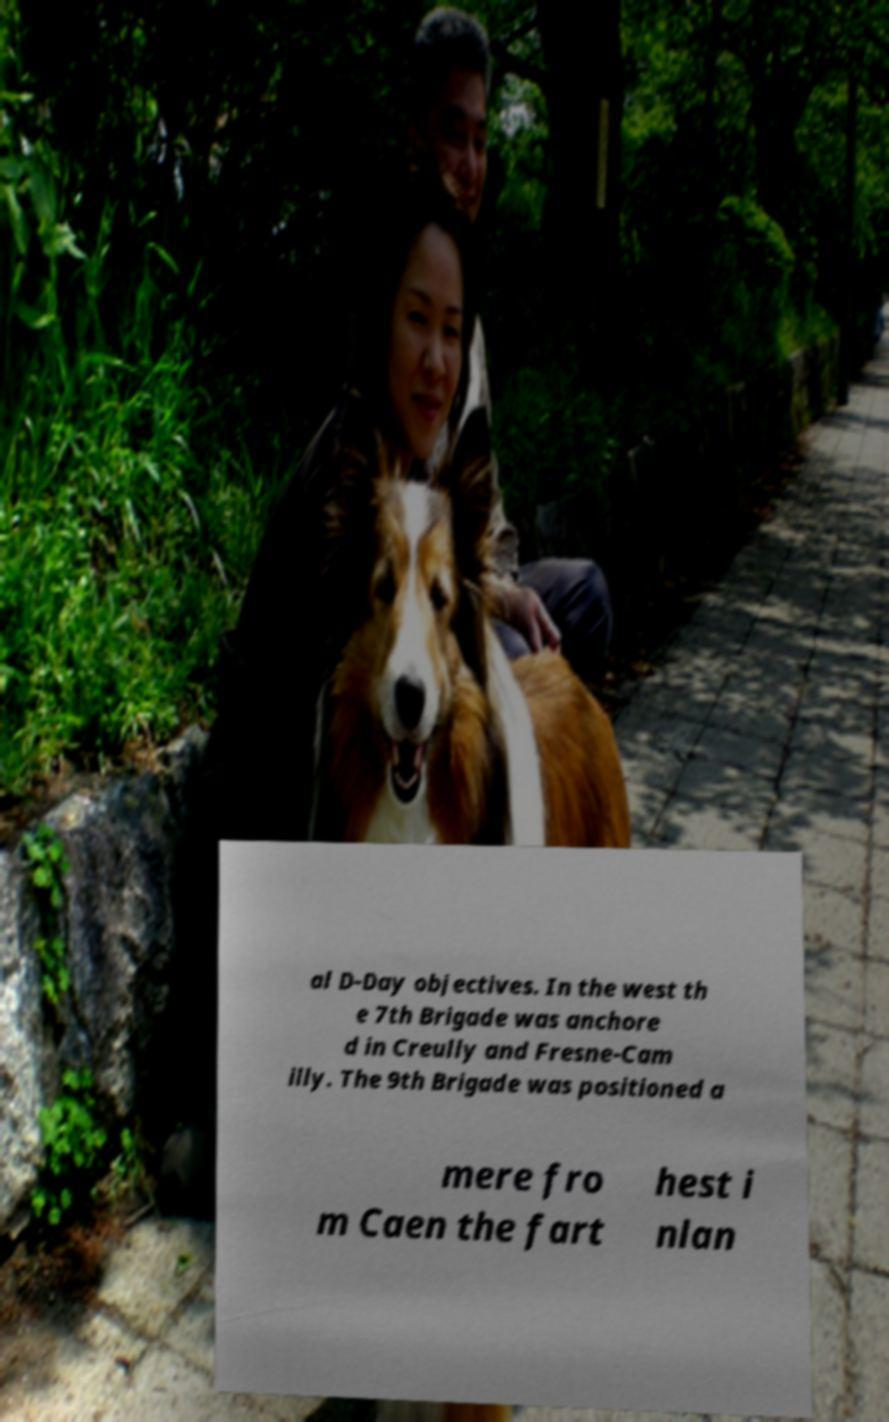Can you accurately transcribe the text from the provided image for me? al D-Day objectives. In the west th e 7th Brigade was anchore d in Creully and Fresne-Cam illy. The 9th Brigade was positioned a mere fro m Caen the fart hest i nlan 